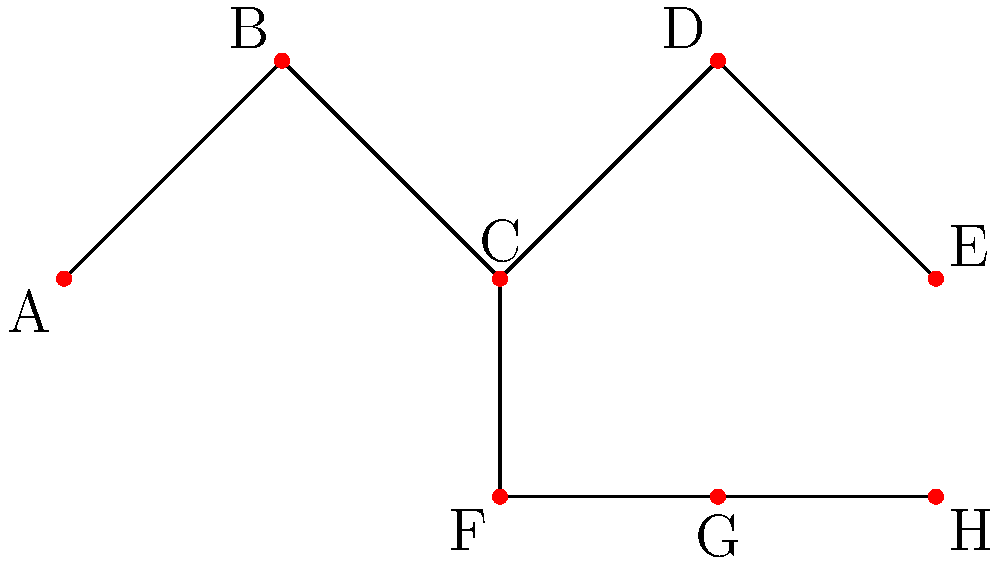In this graph representing player choices in a classic RPG, what is the maximum number of unique paths from node A to any end node, assuming each edge can only be traversed once? To solve this problem, we need to analyze the graph and count the number of unique paths from node A to each end node. Let's break it down step-by-step:

1. Identify the end nodes:
   The end nodes are E and H, as they have no outgoing edges.

2. Count paths to node E:
   A → B → C → D → E
   This is the only path to E, so there is 1 path.

3. Count paths to node H:
   Path 1: A → B → C → F → G → H
   Path 2: A → B → C → D → E (dead end, backtrack to C) → F → G → H

   There are 2 paths to H.

4. Calculate the total number of unique paths:
   Total paths = Paths to E + Paths to H
   Total paths = 1 + 2 = 3

5. Verify the maximum:
   The question asks for the maximum number of unique paths to any end node.
   For E, we have 1 path.
   For H, we have 2 paths.
   The maximum of these is 2.

Therefore, the maximum number of unique paths from node A to any end node is 2.
Answer: 2 